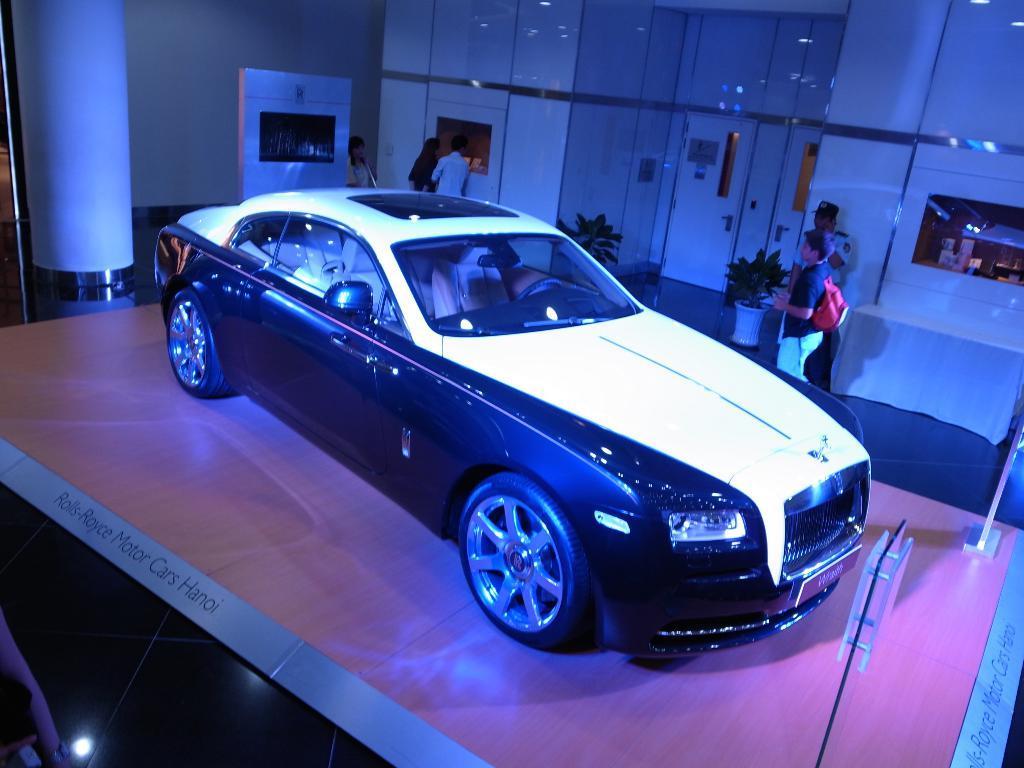Describe this image in one or two sentences. As we can see in the image there is a wall, door, plants, pots, few people here and there and car. 